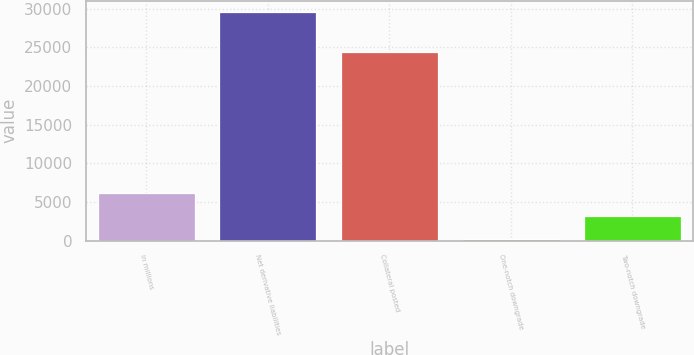<chart> <loc_0><loc_0><loc_500><loc_500><bar_chart><fcel>in millions<fcel>Net derivative liabilities<fcel>Collateral posted<fcel>One-notch downgrade<fcel>Two-notch downgrade<nl><fcel>6126.2<fcel>29583<fcel>24393<fcel>262<fcel>3194.1<nl></chart> 